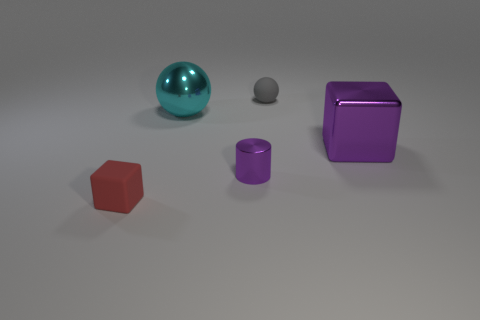Is there anything else that has the same shape as the small metal object?
Keep it short and to the point. No. There is another thing that is the same shape as the big cyan object; what color is it?
Offer a very short reply. Gray. Is the size of the red block the same as the purple metal cylinder?
Make the answer very short. Yes. Are there an equal number of red things on the left side of the large cyan object and purple cylinders?
Offer a very short reply. Yes. There is a small object that is left of the purple shiny cylinder; is there a object to the right of it?
Your response must be concise. Yes. There is a purple shiny object that is in front of the purple metallic cube behind the rubber thing that is on the left side of the small cylinder; how big is it?
Your response must be concise. Small. There is a small purple object in front of the block that is right of the small red object; what is its material?
Make the answer very short. Metal. Are there any cyan rubber things that have the same shape as the red object?
Make the answer very short. No. What shape is the tiny gray thing?
Your response must be concise. Sphere. What is the material of the large thing that is to the right of the matte object behind the thing that is to the left of the cyan sphere?
Ensure brevity in your answer.  Metal. 